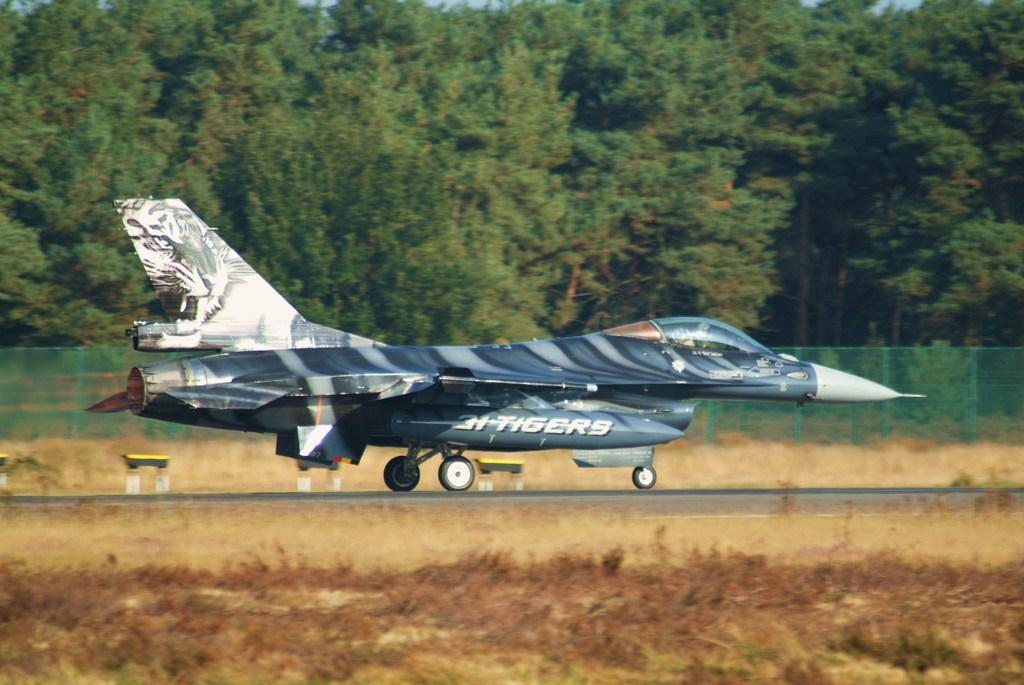What is the unusual object on the road in the image? There is a jet plane on the road in the image. What can be seen in the background of the image? There are iron grilles and trees in the background of the image. What is present on the ground in the image? There are dry leaves and plants on the ground in the image. What famous actor can be seen walking on the road in the image? There is no actor present in the image, and no one is walking on the road. What type of insects can be seen crawling on the plants in the image? There is no mention of insects in the image, and no insects are visible. 